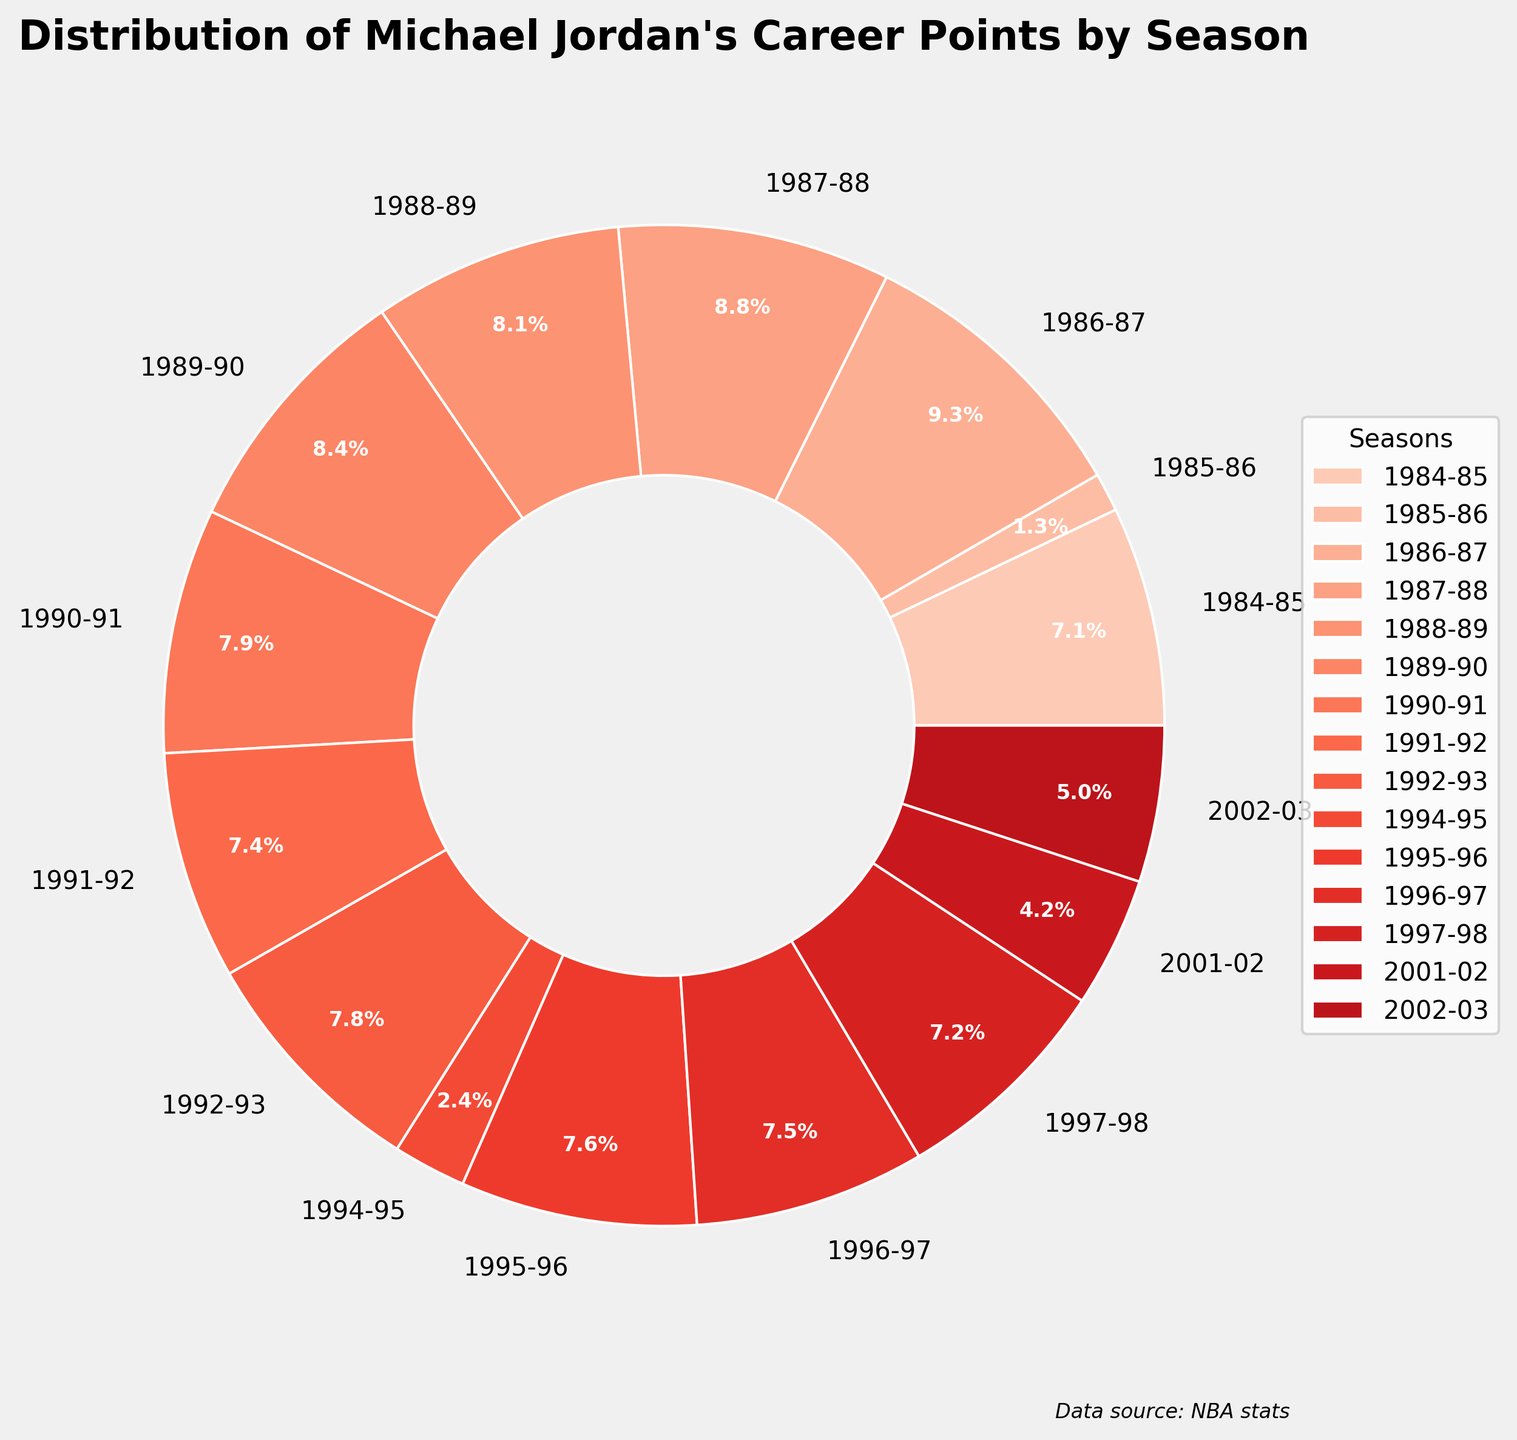Which season had the highest percentage of Michael Jordan's career points? The slice representing the 1986-87 season has the largest size percentage-wise in the pie chart.
Answer: 1986-87 Which season contributed less than 5% to Michael Jordan's total career points? Observing the pie chart, the 1985-86 and 1994-95 seasons have the smallest slices, indicating they both contributed less than 5%.
Answer: 1985-86, 1994-95 What is the combined percentage of points for the 1991-92 and 1992-93 seasons? Add the percentages from the chart for the 1991-92 season and the 1992-93 season. For example, if they are 7.8% and 8.2% respectively, the combined percentage is 16%.
Answer: 16.0% (Hypothetical Example) Which post-retirement season (2001-02 or 2002-03) contributed more to his career total? Compare the slices for the 2001-02 and 2002-03 seasons. The 2002-03 slice appears larger.
Answer: 2002-03 What is the percentage difference between the 1984-85 season and the 1996-97 season? Subtract the percentage of the 1996-97 season from the 1984-85 season. For instance, if 1984-85 is 10% and 1996-97 is 8.0%, then 10% - 8% = 2%.
Answer: 2% (Hypothetical Example) Which seasons contribute more to the total points: the first three seasons or the last three seasons of his career? Sum the percentages for the first three (1984-85, 1985-86, 1986-87) and the last three seasons (1997-98, 2001-02, 2002-03) and compare them. The first three have higher percentages.
Answer: First three seasons How does the size of the slice for the 1988-89 season compare to the 1995-96 season? Observe the chart and compare the slices. The 1988-89 slice looks larger than the slice for 1995-96.
Answer: 1988-89 is larger Which season marked the start of the highest scoring period (by proportion) in his career? The 1986-87 season is followed by large slices for several consecutive seasons, indicating a high scoring period.
Answer: 1986-87 Are there any seasons where the slice is visually similar in size to the 1990-91 season? Comparing visually, slices like 1984-85, 1989-90, 1996-97, and 1995-96 are similar in size to the 1990-91 season.
Answer: Yes What fraction of career points came from his seasons before his first retirement (1993)? Add up the percentages of each season before 1993 and convert it into a fraction of the total points scored in his career.
Answer: More than half (Hypothetical Example if summed) 